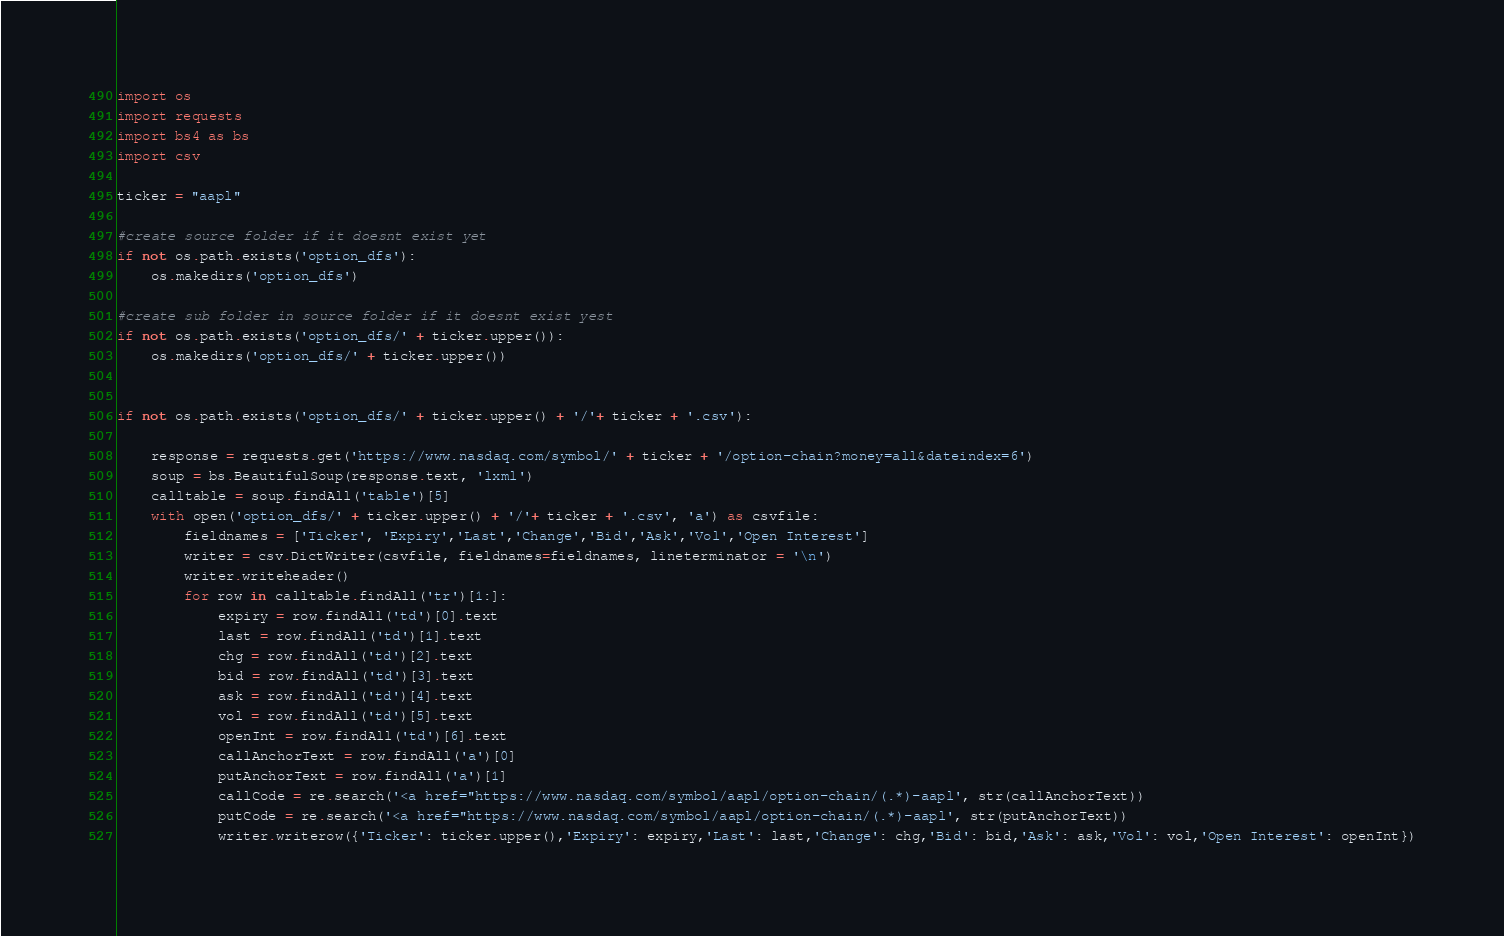Convert code to text. <code><loc_0><loc_0><loc_500><loc_500><_Python_>import os
import requests
import bs4 as bs
import csv

ticker = "aapl"

#create source folder if it doesnt exist yet
if not os.path.exists('option_dfs'):
    os.makedirs('option_dfs')

#create sub folder in source folder if it doesnt exist yest
if not os.path.exists('option_dfs/' + ticker.upper()):
    os.makedirs('option_dfs/' + ticker.upper())

    
if not os.path.exists('option_dfs/' + ticker.upper() + '/'+ ticker + '.csv'):
    
    response = requests.get('https://www.nasdaq.com/symbol/' + ticker + '/option-chain?money=all&dateindex=6')
    soup = bs.BeautifulSoup(response.text, 'lxml')
    calltable = soup.findAll('table')[5]
    with open('option_dfs/' + ticker.upper() + '/'+ ticker + '.csv', 'a') as csvfile:
        fieldnames = ['Ticker', 'Expiry','Last','Change','Bid','Ask','Vol','Open Interest']
        writer = csv.DictWriter(csvfile, fieldnames=fieldnames, lineterminator = '\n')
        writer.writeheader()
        for row in calltable.findAll('tr')[1:]:
            expiry = row.findAll('td')[0].text
            last = row.findAll('td')[1].text
            chg = row.findAll('td')[2].text
            bid = row.findAll('td')[3].text
            ask = row.findAll('td')[4].text
            vol = row.findAll('td')[5].text
            openInt = row.findAll('td')[6].text
            callAnchorText = row.findAll('a')[0]
            putAnchorText = row.findAll('a')[1]
            callCode = re.search('<a href="https://www.nasdaq.com/symbol/aapl/option-chain/(.*)-aapl', str(callAnchorText))
            putCode = re.search('<a href="https://www.nasdaq.com/symbol/aapl/option-chain/(.*)-aapl', str(putAnchorText))
            writer.writerow({'Ticker': ticker.upper(),'Expiry': expiry,'Last': last,'Change': chg,'Bid': bid,'Ask': ask,'Vol': vol,'Open Interest': openInt})
</code> 